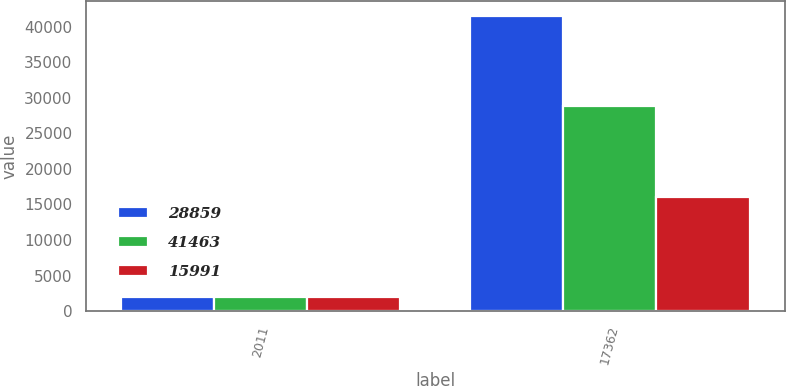Convert chart. <chart><loc_0><loc_0><loc_500><loc_500><stacked_bar_chart><ecel><fcel>2011<fcel>17362<nl><fcel>28859<fcel>2010<fcel>41463<nl><fcel>41463<fcel>2009<fcel>28859<nl><fcel>15991<fcel>2008<fcel>15991<nl></chart> 